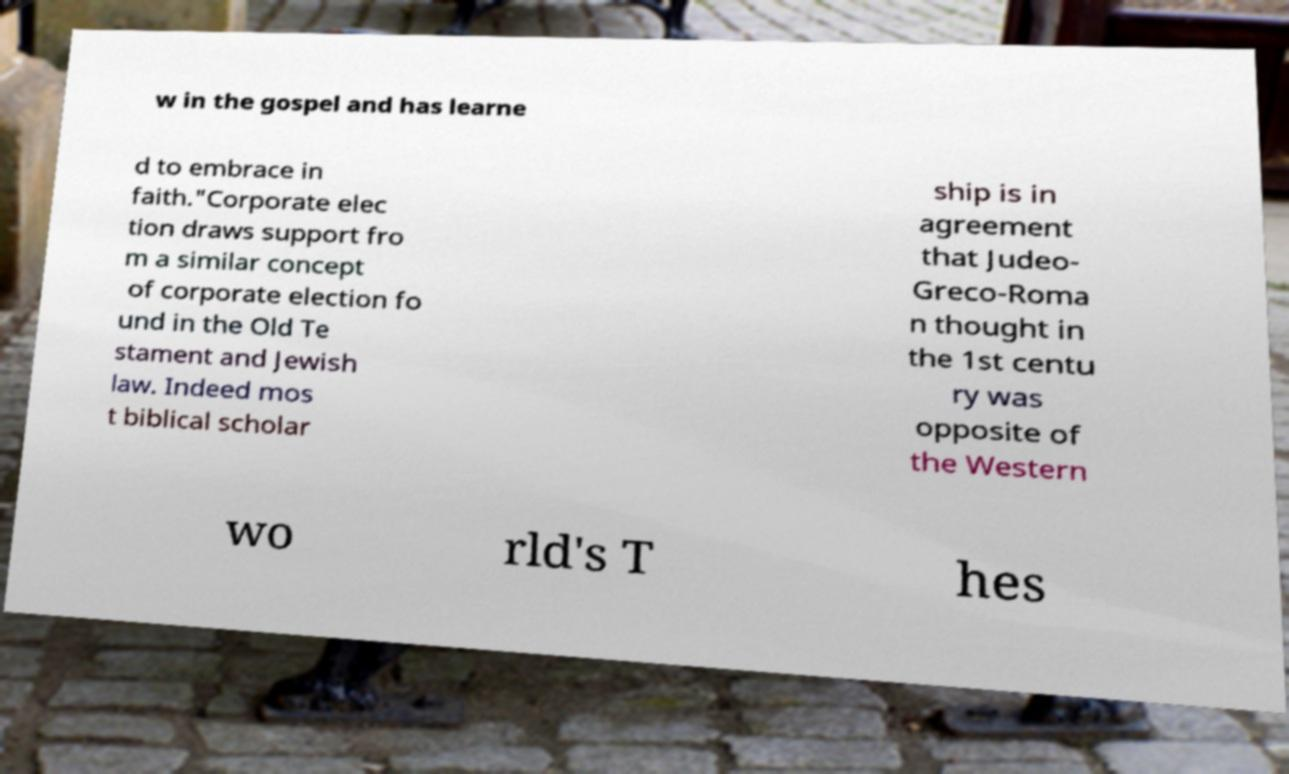Please identify and transcribe the text found in this image. w in the gospel and has learne d to embrace in faith."Corporate elec tion draws support fro m a similar concept of corporate election fo und in the Old Te stament and Jewish law. Indeed mos t biblical scholar ship is in agreement that Judeo- Greco-Roma n thought in the 1st centu ry was opposite of the Western wo rld's T hes 